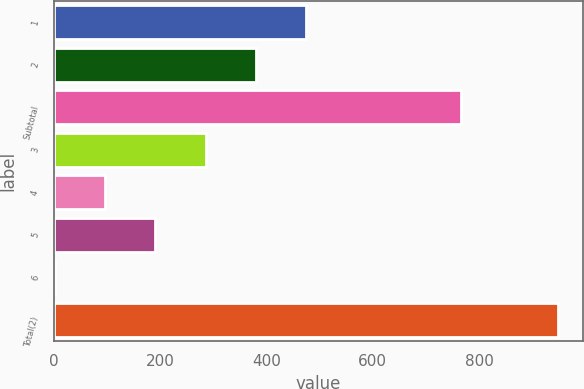Convert chart. <chart><loc_0><loc_0><loc_500><loc_500><bar_chart><fcel>1<fcel>2<fcel>Subtotal<fcel>3<fcel>4<fcel>5<fcel>6<fcel>Total(2)<nl><fcel>474.93<fcel>380.32<fcel>766<fcel>285.71<fcel>96.49<fcel>191.1<fcel>1.88<fcel>948<nl></chart> 